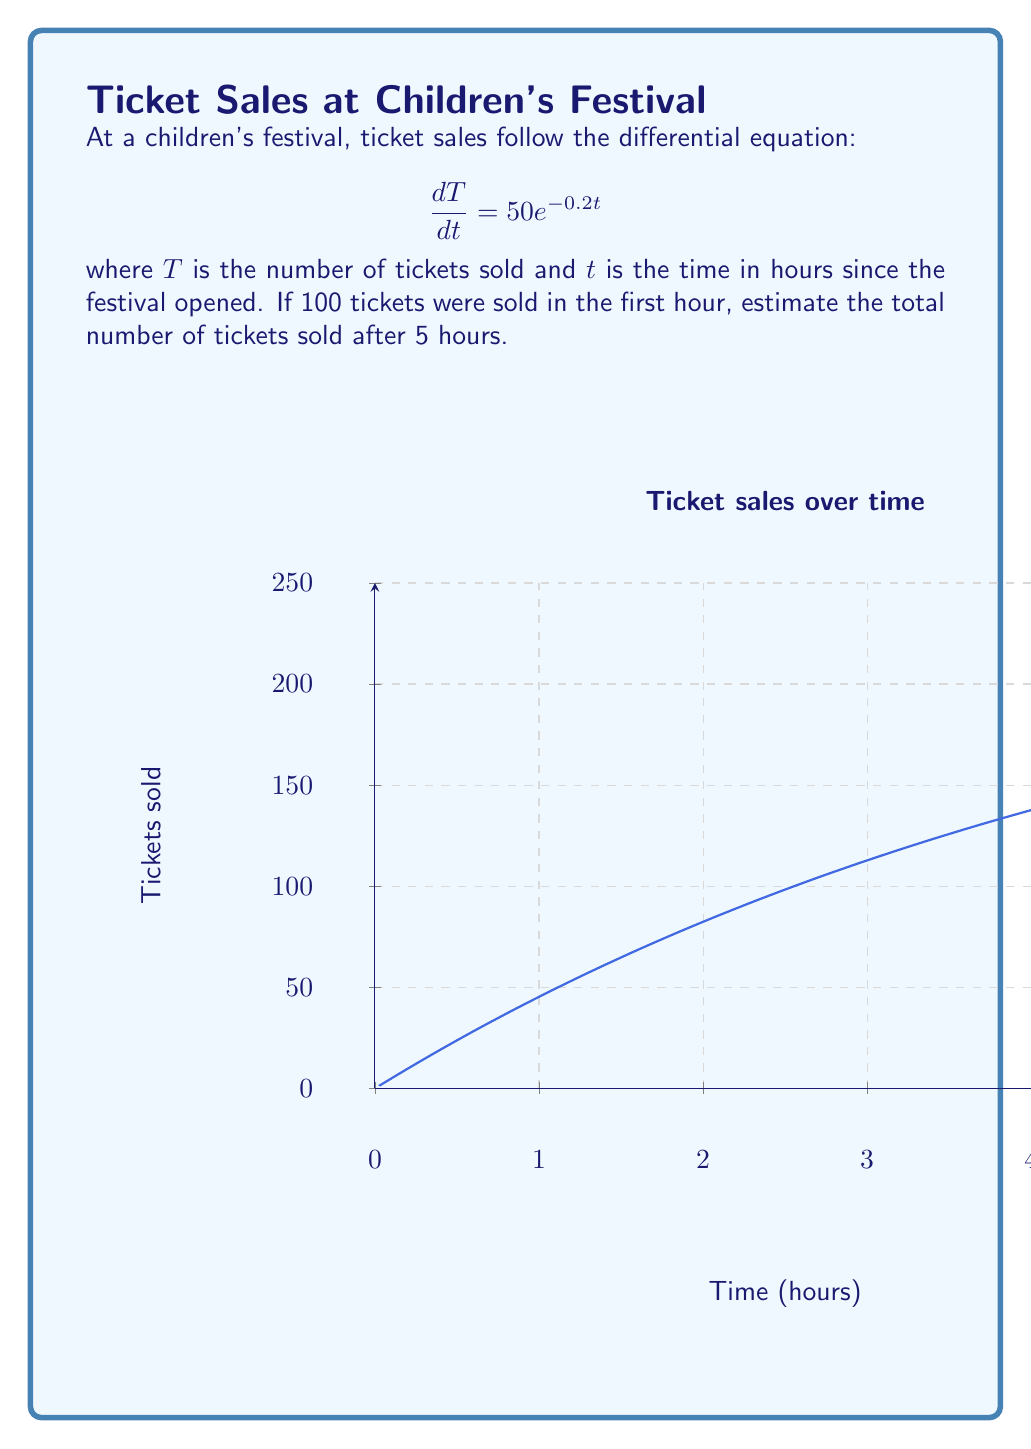Show me your answer to this math problem. Let's approach this step-by-step:

1) The given differential equation is:
   $$\frac{dT}{dt} = 50e^{-0.2t}$$

2) To find the total number of tickets sold, we need to integrate this equation:
   $$T = \int 50e^{-0.2t} dt$$

3) Integrating:
   $$T = -250e^{-0.2t} + C$$
   where $C$ is the constant of integration.

4) To find $C$, we use the initial condition. We know that after 1 hour (t=1), 100 tickets were sold:
   $$100 = -250e^{-0.2(1)} + C$$
   $$100 = -250(0.8187) + C$$
   $$C = 304.675$$

5) So our particular solution is:
   $$T = -250e^{-0.2t} + 304.675$$

6) To find the number of tickets sold after 5 hours, we substitute t=5:
   $$T(5) = -250e^{-0.2(5)} + 304.675$$
   $$T(5) = -250(0.3679) + 304.675$$
   $$T(5) = -91.975 + 304.675$$
   $$T(5) = 212.7$$

7) Rounding to the nearest whole number (as we can't sell partial tickets):
   $$T(5) \approx 213$$
Answer: 213 tickets 